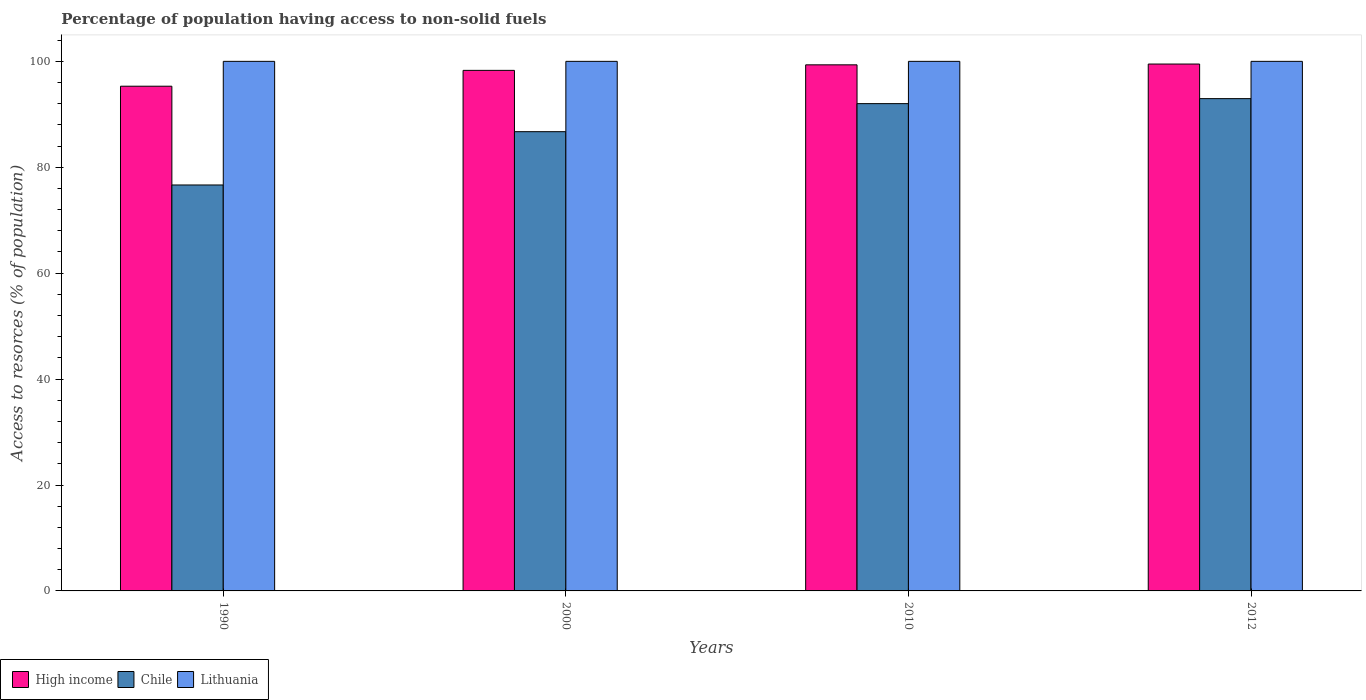Are the number of bars per tick equal to the number of legend labels?
Provide a short and direct response. Yes. What is the percentage of population having access to non-solid fuels in High income in 1990?
Keep it short and to the point. 95.31. Across all years, what is the maximum percentage of population having access to non-solid fuels in High income?
Ensure brevity in your answer.  99.49. Across all years, what is the minimum percentage of population having access to non-solid fuels in High income?
Offer a very short reply. 95.31. In which year was the percentage of population having access to non-solid fuels in Lithuania maximum?
Your response must be concise. 1990. In which year was the percentage of population having access to non-solid fuels in Lithuania minimum?
Provide a short and direct response. 1990. What is the total percentage of population having access to non-solid fuels in High income in the graph?
Offer a terse response. 392.44. What is the difference between the percentage of population having access to non-solid fuels in Lithuania in 2000 and that in 2010?
Offer a very short reply. 0. What is the difference between the percentage of population having access to non-solid fuels in High income in 2000 and the percentage of population having access to non-solid fuels in Chile in 2012?
Your answer should be very brief. 5.34. What is the average percentage of population having access to non-solid fuels in Chile per year?
Your response must be concise. 87.09. In the year 1990, what is the difference between the percentage of population having access to non-solid fuels in Lithuania and percentage of population having access to non-solid fuels in Chile?
Ensure brevity in your answer.  23.34. What is the ratio of the percentage of population having access to non-solid fuels in High income in 2010 to that in 2012?
Give a very brief answer. 1. Is the percentage of population having access to non-solid fuels in High income in 1990 less than that in 2010?
Provide a short and direct response. Yes. What is the difference between the highest and the second highest percentage of population having access to non-solid fuels in High income?
Your answer should be compact. 0.15. What is the difference between the highest and the lowest percentage of population having access to non-solid fuels in High income?
Your answer should be compact. 4.19. Is the sum of the percentage of population having access to non-solid fuels in Chile in 2000 and 2012 greater than the maximum percentage of population having access to non-solid fuels in Lithuania across all years?
Your response must be concise. Yes. What does the 1st bar from the left in 2012 represents?
Give a very brief answer. High income. Is it the case that in every year, the sum of the percentage of population having access to non-solid fuels in High income and percentage of population having access to non-solid fuels in Lithuania is greater than the percentage of population having access to non-solid fuels in Chile?
Your answer should be very brief. Yes. How many bars are there?
Make the answer very short. 12. How many years are there in the graph?
Keep it short and to the point. 4. What is the difference between two consecutive major ticks on the Y-axis?
Provide a short and direct response. 20. Are the values on the major ticks of Y-axis written in scientific E-notation?
Ensure brevity in your answer.  No. Does the graph contain any zero values?
Offer a terse response. No. Does the graph contain grids?
Your response must be concise. No. What is the title of the graph?
Your answer should be compact. Percentage of population having access to non-solid fuels. What is the label or title of the X-axis?
Your answer should be compact. Years. What is the label or title of the Y-axis?
Offer a terse response. Access to resorces (% of population). What is the Access to resorces (% of population) in High income in 1990?
Ensure brevity in your answer.  95.31. What is the Access to resorces (% of population) of Chile in 1990?
Make the answer very short. 76.66. What is the Access to resorces (% of population) in Lithuania in 1990?
Your answer should be very brief. 100. What is the Access to resorces (% of population) of High income in 2000?
Your answer should be very brief. 98.3. What is the Access to resorces (% of population) of Chile in 2000?
Your answer should be compact. 86.72. What is the Access to resorces (% of population) in High income in 2010?
Your answer should be compact. 99.34. What is the Access to resorces (% of population) in Chile in 2010?
Offer a terse response. 92.02. What is the Access to resorces (% of population) in Lithuania in 2010?
Make the answer very short. 100. What is the Access to resorces (% of population) of High income in 2012?
Make the answer very short. 99.49. What is the Access to resorces (% of population) in Chile in 2012?
Your answer should be very brief. 92.96. Across all years, what is the maximum Access to resorces (% of population) in High income?
Your answer should be very brief. 99.49. Across all years, what is the maximum Access to resorces (% of population) in Chile?
Your response must be concise. 92.96. Across all years, what is the minimum Access to resorces (% of population) of High income?
Give a very brief answer. 95.31. Across all years, what is the minimum Access to resorces (% of population) in Chile?
Offer a very short reply. 76.66. Across all years, what is the minimum Access to resorces (% of population) in Lithuania?
Provide a succinct answer. 100. What is the total Access to resorces (% of population) in High income in the graph?
Your answer should be compact. 392.44. What is the total Access to resorces (% of population) in Chile in the graph?
Give a very brief answer. 348.35. What is the total Access to resorces (% of population) of Lithuania in the graph?
Provide a short and direct response. 400. What is the difference between the Access to resorces (% of population) of High income in 1990 and that in 2000?
Provide a short and direct response. -2.99. What is the difference between the Access to resorces (% of population) in Chile in 1990 and that in 2000?
Your answer should be compact. -10.06. What is the difference between the Access to resorces (% of population) in Lithuania in 1990 and that in 2000?
Provide a succinct answer. 0. What is the difference between the Access to resorces (% of population) in High income in 1990 and that in 2010?
Your answer should be very brief. -4.04. What is the difference between the Access to resorces (% of population) in Chile in 1990 and that in 2010?
Provide a short and direct response. -15.36. What is the difference between the Access to resorces (% of population) of High income in 1990 and that in 2012?
Provide a short and direct response. -4.19. What is the difference between the Access to resorces (% of population) of Chile in 1990 and that in 2012?
Your response must be concise. -16.3. What is the difference between the Access to resorces (% of population) of High income in 2000 and that in 2010?
Make the answer very short. -1.04. What is the difference between the Access to resorces (% of population) in Chile in 2000 and that in 2010?
Your answer should be compact. -5.3. What is the difference between the Access to resorces (% of population) in Lithuania in 2000 and that in 2010?
Provide a succinct answer. 0. What is the difference between the Access to resorces (% of population) in High income in 2000 and that in 2012?
Provide a succinct answer. -1.2. What is the difference between the Access to resorces (% of population) in Chile in 2000 and that in 2012?
Offer a very short reply. -6.24. What is the difference between the Access to resorces (% of population) of Lithuania in 2000 and that in 2012?
Your answer should be very brief. 0. What is the difference between the Access to resorces (% of population) of High income in 2010 and that in 2012?
Provide a short and direct response. -0.15. What is the difference between the Access to resorces (% of population) of Chile in 2010 and that in 2012?
Give a very brief answer. -0.94. What is the difference between the Access to resorces (% of population) in High income in 1990 and the Access to resorces (% of population) in Chile in 2000?
Your response must be concise. 8.59. What is the difference between the Access to resorces (% of population) of High income in 1990 and the Access to resorces (% of population) of Lithuania in 2000?
Provide a succinct answer. -4.69. What is the difference between the Access to resorces (% of population) of Chile in 1990 and the Access to resorces (% of population) of Lithuania in 2000?
Offer a very short reply. -23.34. What is the difference between the Access to resorces (% of population) of High income in 1990 and the Access to resorces (% of population) of Chile in 2010?
Make the answer very short. 3.29. What is the difference between the Access to resorces (% of population) of High income in 1990 and the Access to resorces (% of population) of Lithuania in 2010?
Offer a very short reply. -4.69. What is the difference between the Access to resorces (% of population) in Chile in 1990 and the Access to resorces (% of population) in Lithuania in 2010?
Your answer should be very brief. -23.34. What is the difference between the Access to resorces (% of population) in High income in 1990 and the Access to resorces (% of population) in Chile in 2012?
Provide a short and direct response. 2.35. What is the difference between the Access to resorces (% of population) in High income in 1990 and the Access to resorces (% of population) in Lithuania in 2012?
Offer a very short reply. -4.69. What is the difference between the Access to resorces (% of population) of Chile in 1990 and the Access to resorces (% of population) of Lithuania in 2012?
Keep it short and to the point. -23.34. What is the difference between the Access to resorces (% of population) in High income in 2000 and the Access to resorces (% of population) in Chile in 2010?
Offer a terse response. 6.28. What is the difference between the Access to resorces (% of population) in High income in 2000 and the Access to resorces (% of population) in Lithuania in 2010?
Offer a very short reply. -1.7. What is the difference between the Access to resorces (% of population) in Chile in 2000 and the Access to resorces (% of population) in Lithuania in 2010?
Make the answer very short. -13.28. What is the difference between the Access to resorces (% of population) in High income in 2000 and the Access to resorces (% of population) in Chile in 2012?
Provide a short and direct response. 5.34. What is the difference between the Access to resorces (% of population) of High income in 2000 and the Access to resorces (% of population) of Lithuania in 2012?
Give a very brief answer. -1.7. What is the difference between the Access to resorces (% of population) of Chile in 2000 and the Access to resorces (% of population) of Lithuania in 2012?
Your answer should be very brief. -13.28. What is the difference between the Access to resorces (% of population) in High income in 2010 and the Access to resorces (% of population) in Chile in 2012?
Ensure brevity in your answer.  6.38. What is the difference between the Access to resorces (% of population) of High income in 2010 and the Access to resorces (% of population) of Lithuania in 2012?
Your answer should be very brief. -0.66. What is the difference between the Access to resorces (% of population) of Chile in 2010 and the Access to resorces (% of population) of Lithuania in 2012?
Make the answer very short. -7.98. What is the average Access to resorces (% of population) of High income per year?
Make the answer very short. 98.11. What is the average Access to resorces (% of population) of Chile per year?
Your answer should be very brief. 87.09. What is the average Access to resorces (% of population) in Lithuania per year?
Ensure brevity in your answer.  100. In the year 1990, what is the difference between the Access to resorces (% of population) in High income and Access to resorces (% of population) in Chile?
Keep it short and to the point. 18.65. In the year 1990, what is the difference between the Access to resorces (% of population) of High income and Access to resorces (% of population) of Lithuania?
Your response must be concise. -4.69. In the year 1990, what is the difference between the Access to resorces (% of population) in Chile and Access to resorces (% of population) in Lithuania?
Offer a very short reply. -23.34. In the year 2000, what is the difference between the Access to resorces (% of population) in High income and Access to resorces (% of population) in Chile?
Your answer should be compact. 11.58. In the year 2000, what is the difference between the Access to resorces (% of population) of High income and Access to resorces (% of population) of Lithuania?
Ensure brevity in your answer.  -1.7. In the year 2000, what is the difference between the Access to resorces (% of population) in Chile and Access to resorces (% of population) in Lithuania?
Give a very brief answer. -13.28. In the year 2010, what is the difference between the Access to resorces (% of population) in High income and Access to resorces (% of population) in Chile?
Keep it short and to the point. 7.33. In the year 2010, what is the difference between the Access to resorces (% of population) of High income and Access to resorces (% of population) of Lithuania?
Your answer should be very brief. -0.66. In the year 2010, what is the difference between the Access to resorces (% of population) of Chile and Access to resorces (% of population) of Lithuania?
Your response must be concise. -7.98. In the year 2012, what is the difference between the Access to resorces (% of population) in High income and Access to resorces (% of population) in Chile?
Provide a short and direct response. 6.53. In the year 2012, what is the difference between the Access to resorces (% of population) of High income and Access to resorces (% of population) of Lithuania?
Provide a short and direct response. -0.51. In the year 2012, what is the difference between the Access to resorces (% of population) in Chile and Access to resorces (% of population) in Lithuania?
Offer a very short reply. -7.04. What is the ratio of the Access to resorces (% of population) of High income in 1990 to that in 2000?
Your answer should be compact. 0.97. What is the ratio of the Access to resorces (% of population) of Chile in 1990 to that in 2000?
Keep it short and to the point. 0.88. What is the ratio of the Access to resorces (% of population) in High income in 1990 to that in 2010?
Make the answer very short. 0.96. What is the ratio of the Access to resorces (% of population) in Chile in 1990 to that in 2010?
Give a very brief answer. 0.83. What is the ratio of the Access to resorces (% of population) in Lithuania in 1990 to that in 2010?
Your response must be concise. 1. What is the ratio of the Access to resorces (% of population) of High income in 1990 to that in 2012?
Provide a short and direct response. 0.96. What is the ratio of the Access to resorces (% of population) in Chile in 1990 to that in 2012?
Give a very brief answer. 0.82. What is the ratio of the Access to resorces (% of population) in High income in 2000 to that in 2010?
Ensure brevity in your answer.  0.99. What is the ratio of the Access to resorces (% of population) of Chile in 2000 to that in 2010?
Make the answer very short. 0.94. What is the ratio of the Access to resorces (% of population) in Lithuania in 2000 to that in 2010?
Offer a very short reply. 1. What is the ratio of the Access to resorces (% of population) of Chile in 2000 to that in 2012?
Give a very brief answer. 0.93. What is the ratio of the Access to resorces (% of population) in High income in 2010 to that in 2012?
Offer a very short reply. 1. What is the difference between the highest and the second highest Access to resorces (% of population) in High income?
Your answer should be very brief. 0.15. What is the difference between the highest and the second highest Access to resorces (% of population) in Chile?
Give a very brief answer. 0.94. What is the difference between the highest and the second highest Access to resorces (% of population) in Lithuania?
Your response must be concise. 0. What is the difference between the highest and the lowest Access to resorces (% of population) in High income?
Offer a very short reply. 4.19. What is the difference between the highest and the lowest Access to resorces (% of population) of Chile?
Keep it short and to the point. 16.3. 